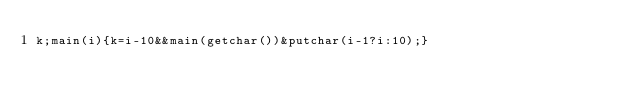Convert code to text. <code><loc_0><loc_0><loc_500><loc_500><_C_>k;main(i){k=i-10&&main(getchar())&putchar(i-1?i:10);}</code> 